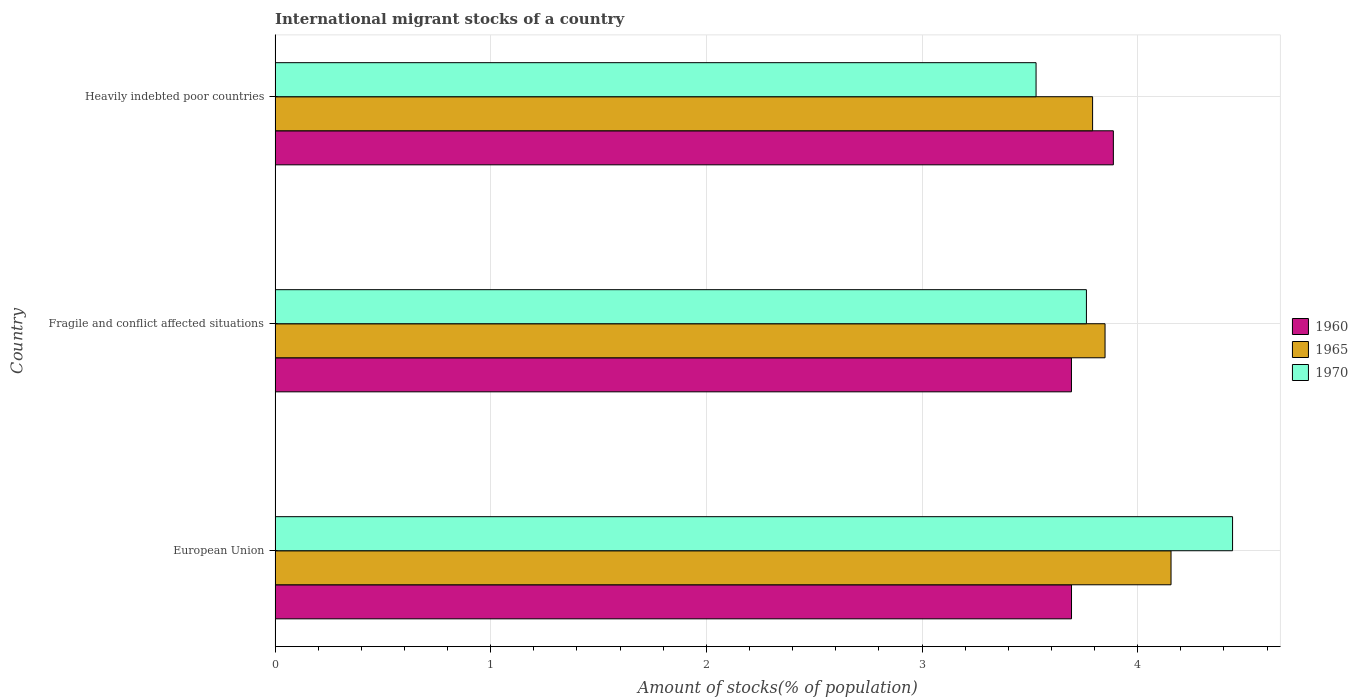Are the number of bars per tick equal to the number of legend labels?
Ensure brevity in your answer.  Yes. What is the label of the 1st group of bars from the top?
Your answer should be compact. Heavily indebted poor countries. What is the amount of stocks in in 1965 in European Union?
Your answer should be compact. 4.15. Across all countries, what is the maximum amount of stocks in in 1960?
Offer a terse response. 3.89. Across all countries, what is the minimum amount of stocks in in 1960?
Offer a very short reply. 3.69. In which country was the amount of stocks in in 1965 minimum?
Make the answer very short. Heavily indebted poor countries. What is the total amount of stocks in in 1965 in the graph?
Your response must be concise. 11.79. What is the difference between the amount of stocks in in 1960 in Fragile and conflict affected situations and that in Heavily indebted poor countries?
Make the answer very short. -0.19. What is the difference between the amount of stocks in in 1960 in Heavily indebted poor countries and the amount of stocks in in 1970 in European Union?
Offer a terse response. -0.55. What is the average amount of stocks in in 1965 per country?
Make the answer very short. 3.93. What is the difference between the amount of stocks in in 1960 and amount of stocks in in 1965 in Fragile and conflict affected situations?
Provide a short and direct response. -0.16. What is the ratio of the amount of stocks in in 1970 in Fragile and conflict affected situations to that in Heavily indebted poor countries?
Ensure brevity in your answer.  1.07. What is the difference between the highest and the second highest amount of stocks in in 1970?
Offer a very short reply. 0.68. What is the difference between the highest and the lowest amount of stocks in in 1960?
Provide a short and direct response. 0.19. In how many countries, is the amount of stocks in in 1970 greater than the average amount of stocks in in 1970 taken over all countries?
Keep it short and to the point. 1. What does the 2nd bar from the bottom in Fragile and conflict affected situations represents?
Keep it short and to the point. 1965. How many bars are there?
Your response must be concise. 9. How many countries are there in the graph?
Your answer should be very brief. 3. Does the graph contain grids?
Your answer should be compact. Yes. How are the legend labels stacked?
Offer a terse response. Vertical. What is the title of the graph?
Make the answer very short. International migrant stocks of a country. Does "1993" appear as one of the legend labels in the graph?
Provide a succinct answer. No. What is the label or title of the X-axis?
Ensure brevity in your answer.  Amount of stocks(% of population). What is the label or title of the Y-axis?
Provide a succinct answer. Country. What is the Amount of stocks(% of population) in 1960 in European Union?
Provide a succinct answer. 3.69. What is the Amount of stocks(% of population) of 1965 in European Union?
Provide a short and direct response. 4.15. What is the Amount of stocks(% of population) of 1970 in European Union?
Provide a succinct answer. 4.44. What is the Amount of stocks(% of population) of 1960 in Fragile and conflict affected situations?
Give a very brief answer. 3.69. What is the Amount of stocks(% of population) of 1965 in Fragile and conflict affected situations?
Make the answer very short. 3.85. What is the Amount of stocks(% of population) in 1970 in Fragile and conflict affected situations?
Give a very brief answer. 3.76. What is the Amount of stocks(% of population) of 1960 in Heavily indebted poor countries?
Keep it short and to the point. 3.89. What is the Amount of stocks(% of population) of 1965 in Heavily indebted poor countries?
Offer a very short reply. 3.79. What is the Amount of stocks(% of population) in 1970 in Heavily indebted poor countries?
Ensure brevity in your answer.  3.53. Across all countries, what is the maximum Amount of stocks(% of population) of 1960?
Give a very brief answer. 3.89. Across all countries, what is the maximum Amount of stocks(% of population) of 1965?
Provide a short and direct response. 4.15. Across all countries, what is the maximum Amount of stocks(% of population) in 1970?
Your answer should be very brief. 4.44. Across all countries, what is the minimum Amount of stocks(% of population) of 1960?
Keep it short and to the point. 3.69. Across all countries, what is the minimum Amount of stocks(% of population) of 1965?
Keep it short and to the point. 3.79. Across all countries, what is the minimum Amount of stocks(% of population) of 1970?
Offer a very short reply. 3.53. What is the total Amount of stocks(% of population) in 1960 in the graph?
Give a very brief answer. 11.27. What is the total Amount of stocks(% of population) of 1965 in the graph?
Provide a short and direct response. 11.79. What is the total Amount of stocks(% of population) in 1970 in the graph?
Give a very brief answer. 11.73. What is the difference between the Amount of stocks(% of population) of 1965 in European Union and that in Fragile and conflict affected situations?
Offer a terse response. 0.31. What is the difference between the Amount of stocks(% of population) of 1970 in European Union and that in Fragile and conflict affected situations?
Your response must be concise. 0.68. What is the difference between the Amount of stocks(% of population) in 1960 in European Union and that in Heavily indebted poor countries?
Provide a succinct answer. -0.19. What is the difference between the Amount of stocks(% of population) of 1965 in European Union and that in Heavily indebted poor countries?
Ensure brevity in your answer.  0.36. What is the difference between the Amount of stocks(% of population) of 1970 in European Union and that in Heavily indebted poor countries?
Provide a succinct answer. 0.91. What is the difference between the Amount of stocks(% of population) in 1960 in Fragile and conflict affected situations and that in Heavily indebted poor countries?
Offer a terse response. -0.19. What is the difference between the Amount of stocks(% of population) in 1965 in Fragile and conflict affected situations and that in Heavily indebted poor countries?
Your answer should be very brief. 0.06. What is the difference between the Amount of stocks(% of population) in 1970 in Fragile and conflict affected situations and that in Heavily indebted poor countries?
Offer a very short reply. 0.23. What is the difference between the Amount of stocks(% of population) of 1960 in European Union and the Amount of stocks(% of population) of 1965 in Fragile and conflict affected situations?
Provide a succinct answer. -0.16. What is the difference between the Amount of stocks(% of population) of 1960 in European Union and the Amount of stocks(% of population) of 1970 in Fragile and conflict affected situations?
Ensure brevity in your answer.  -0.07. What is the difference between the Amount of stocks(% of population) of 1965 in European Union and the Amount of stocks(% of population) of 1970 in Fragile and conflict affected situations?
Your answer should be very brief. 0.39. What is the difference between the Amount of stocks(% of population) of 1960 in European Union and the Amount of stocks(% of population) of 1965 in Heavily indebted poor countries?
Provide a succinct answer. -0.1. What is the difference between the Amount of stocks(% of population) in 1960 in European Union and the Amount of stocks(% of population) in 1970 in Heavily indebted poor countries?
Offer a very short reply. 0.16. What is the difference between the Amount of stocks(% of population) of 1965 in European Union and the Amount of stocks(% of population) of 1970 in Heavily indebted poor countries?
Your response must be concise. 0.63. What is the difference between the Amount of stocks(% of population) in 1960 in Fragile and conflict affected situations and the Amount of stocks(% of population) in 1965 in Heavily indebted poor countries?
Offer a very short reply. -0.1. What is the difference between the Amount of stocks(% of population) in 1960 in Fragile and conflict affected situations and the Amount of stocks(% of population) in 1970 in Heavily indebted poor countries?
Offer a terse response. 0.16. What is the difference between the Amount of stocks(% of population) of 1965 in Fragile and conflict affected situations and the Amount of stocks(% of population) of 1970 in Heavily indebted poor countries?
Provide a short and direct response. 0.32. What is the average Amount of stocks(% of population) of 1960 per country?
Your answer should be very brief. 3.76. What is the average Amount of stocks(% of population) in 1965 per country?
Make the answer very short. 3.93. What is the average Amount of stocks(% of population) in 1970 per country?
Provide a short and direct response. 3.91. What is the difference between the Amount of stocks(% of population) of 1960 and Amount of stocks(% of population) of 1965 in European Union?
Your answer should be very brief. -0.46. What is the difference between the Amount of stocks(% of population) of 1960 and Amount of stocks(% of population) of 1970 in European Union?
Provide a short and direct response. -0.75. What is the difference between the Amount of stocks(% of population) in 1965 and Amount of stocks(% of population) in 1970 in European Union?
Ensure brevity in your answer.  -0.29. What is the difference between the Amount of stocks(% of population) of 1960 and Amount of stocks(% of population) of 1965 in Fragile and conflict affected situations?
Offer a very short reply. -0.16. What is the difference between the Amount of stocks(% of population) of 1960 and Amount of stocks(% of population) of 1970 in Fragile and conflict affected situations?
Make the answer very short. -0.07. What is the difference between the Amount of stocks(% of population) in 1965 and Amount of stocks(% of population) in 1970 in Fragile and conflict affected situations?
Make the answer very short. 0.09. What is the difference between the Amount of stocks(% of population) of 1960 and Amount of stocks(% of population) of 1965 in Heavily indebted poor countries?
Offer a terse response. 0.1. What is the difference between the Amount of stocks(% of population) in 1960 and Amount of stocks(% of population) in 1970 in Heavily indebted poor countries?
Provide a short and direct response. 0.36. What is the difference between the Amount of stocks(% of population) in 1965 and Amount of stocks(% of population) in 1970 in Heavily indebted poor countries?
Keep it short and to the point. 0.26. What is the ratio of the Amount of stocks(% of population) in 1965 in European Union to that in Fragile and conflict affected situations?
Give a very brief answer. 1.08. What is the ratio of the Amount of stocks(% of population) of 1970 in European Union to that in Fragile and conflict affected situations?
Make the answer very short. 1.18. What is the ratio of the Amount of stocks(% of population) of 1960 in European Union to that in Heavily indebted poor countries?
Provide a short and direct response. 0.95. What is the ratio of the Amount of stocks(% of population) in 1965 in European Union to that in Heavily indebted poor countries?
Make the answer very short. 1.1. What is the ratio of the Amount of stocks(% of population) in 1970 in European Union to that in Heavily indebted poor countries?
Make the answer very short. 1.26. What is the ratio of the Amount of stocks(% of population) of 1960 in Fragile and conflict affected situations to that in Heavily indebted poor countries?
Offer a terse response. 0.95. What is the ratio of the Amount of stocks(% of population) of 1965 in Fragile and conflict affected situations to that in Heavily indebted poor countries?
Your answer should be very brief. 1.02. What is the ratio of the Amount of stocks(% of population) in 1970 in Fragile and conflict affected situations to that in Heavily indebted poor countries?
Ensure brevity in your answer.  1.07. What is the difference between the highest and the second highest Amount of stocks(% of population) of 1960?
Keep it short and to the point. 0.19. What is the difference between the highest and the second highest Amount of stocks(% of population) of 1965?
Make the answer very short. 0.31. What is the difference between the highest and the second highest Amount of stocks(% of population) of 1970?
Give a very brief answer. 0.68. What is the difference between the highest and the lowest Amount of stocks(% of population) in 1960?
Your answer should be compact. 0.19. What is the difference between the highest and the lowest Amount of stocks(% of population) of 1965?
Your answer should be very brief. 0.36. What is the difference between the highest and the lowest Amount of stocks(% of population) of 1970?
Keep it short and to the point. 0.91. 